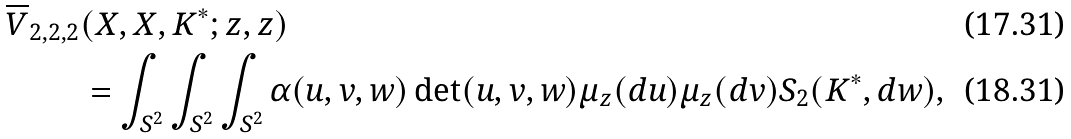<formula> <loc_0><loc_0><loc_500><loc_500>\overline { V } _ { 2 , 2 , 2 } & ( X , X , K ^ { * } ; z , z ) \\ & = \int _ { S ^ { 2 } } \int _ { S ^ { 2 } } \int _ { S ^ { 2 } } \alpha ( u , v , w ) \det ( u , v , w ) \mu _ { z } ( d u ) \mu _ { z } ( d v ) S _ { 2 } ( K ^ { * } , d w ) ,</formula> 